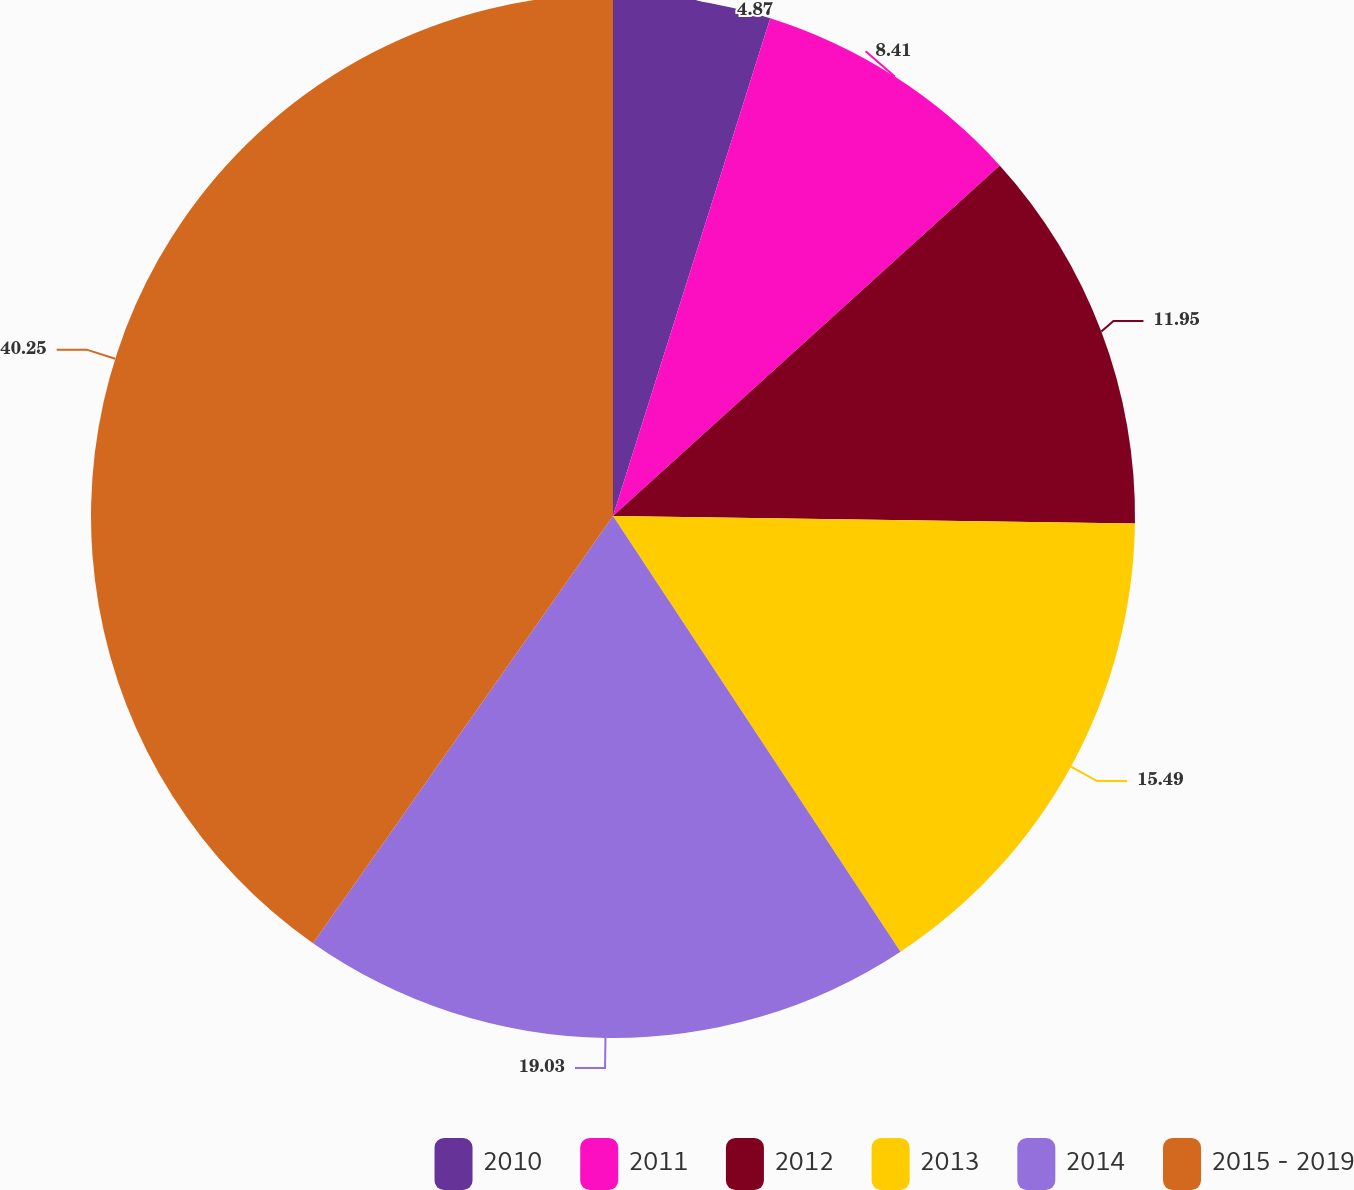<chart> <loc_0><loc_0><loc_500><loc_500><pie_chart><fcel>2010<fcel>2011<fcel>2012<fcel>2013<fcel>2014<fcel>2015 - 2019<nl><fcel>4.87%<fcel>8.41%<fcel>11.95%<fcel>15.49%<fcel>19.03%<fcel>40.26%<nl></chart> 